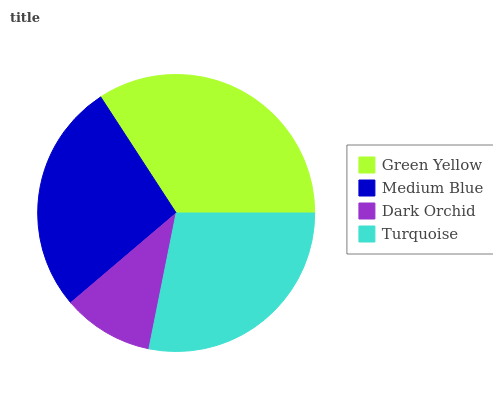Is Dark Orchid the minimum?
Answer yes or no. Yes. Is Green Yellow the maximum?
Answer yes or no. Yes. Is Medium Blue the minimum?
Answer yes or no. No. Is Medium Blue the maximum?
Answer yes or no. No. Is Green Yellow greater than Medium Blue?
Answer yes or no. Yes. Is Medium Blue less than Green Yellow?
Answer yes or no. Yes. Is Medium Blue greater than Green Yellow?
Answer yes or no. No. Is Green Yellow less than Medium Blue?
Answer yes or no. No. Is Turquoise the high median?
Answer yes or no. Yes. Is Medium Blue the low median?
Answer yes or no. Yes. Is Dark Orchid the high median?
Answer yes or no. No. Is Green Yellow the low median?
Answer yes or no. No. 